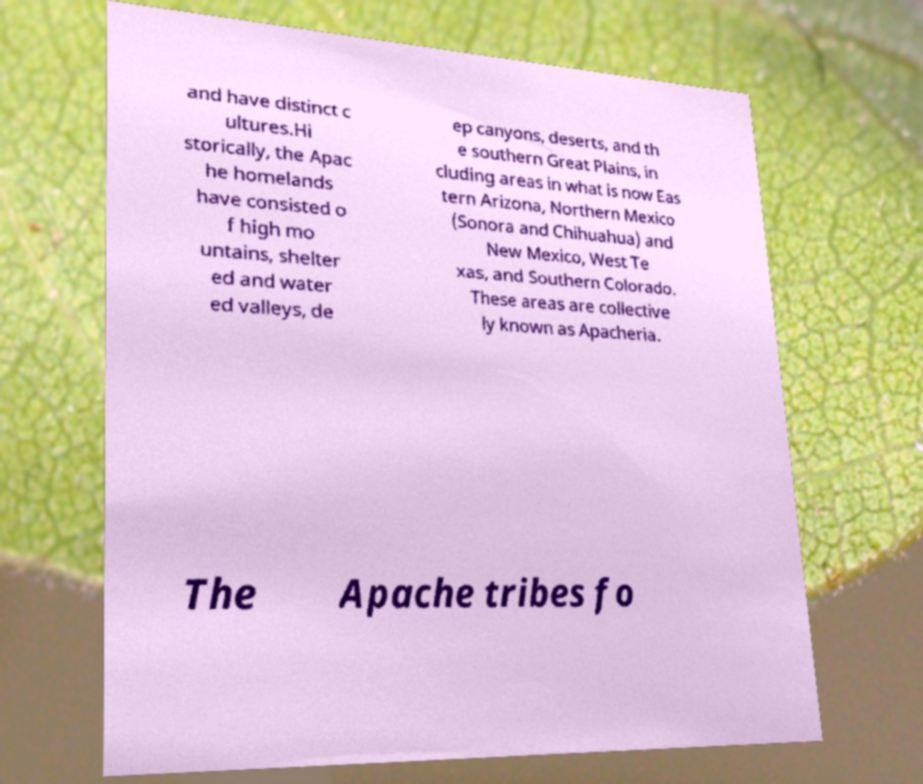Could you assist in decoding the text presented in this image and type it out clearly? and have distinct c ultures.Hi storically, the Apac he homelands have consisted o f high mo untains, shelter ed and water ed valleys, de ep canyons, deserts, and th e southern Great Plains, in cluding areas in what is now Eas tern Arizona, Northern Mexico (Sonora and Chihuahua) and New Mexico, West Te xas, and Southern Colorado. These areas are collective ly known as Apacheria. The Apache tribes fo 